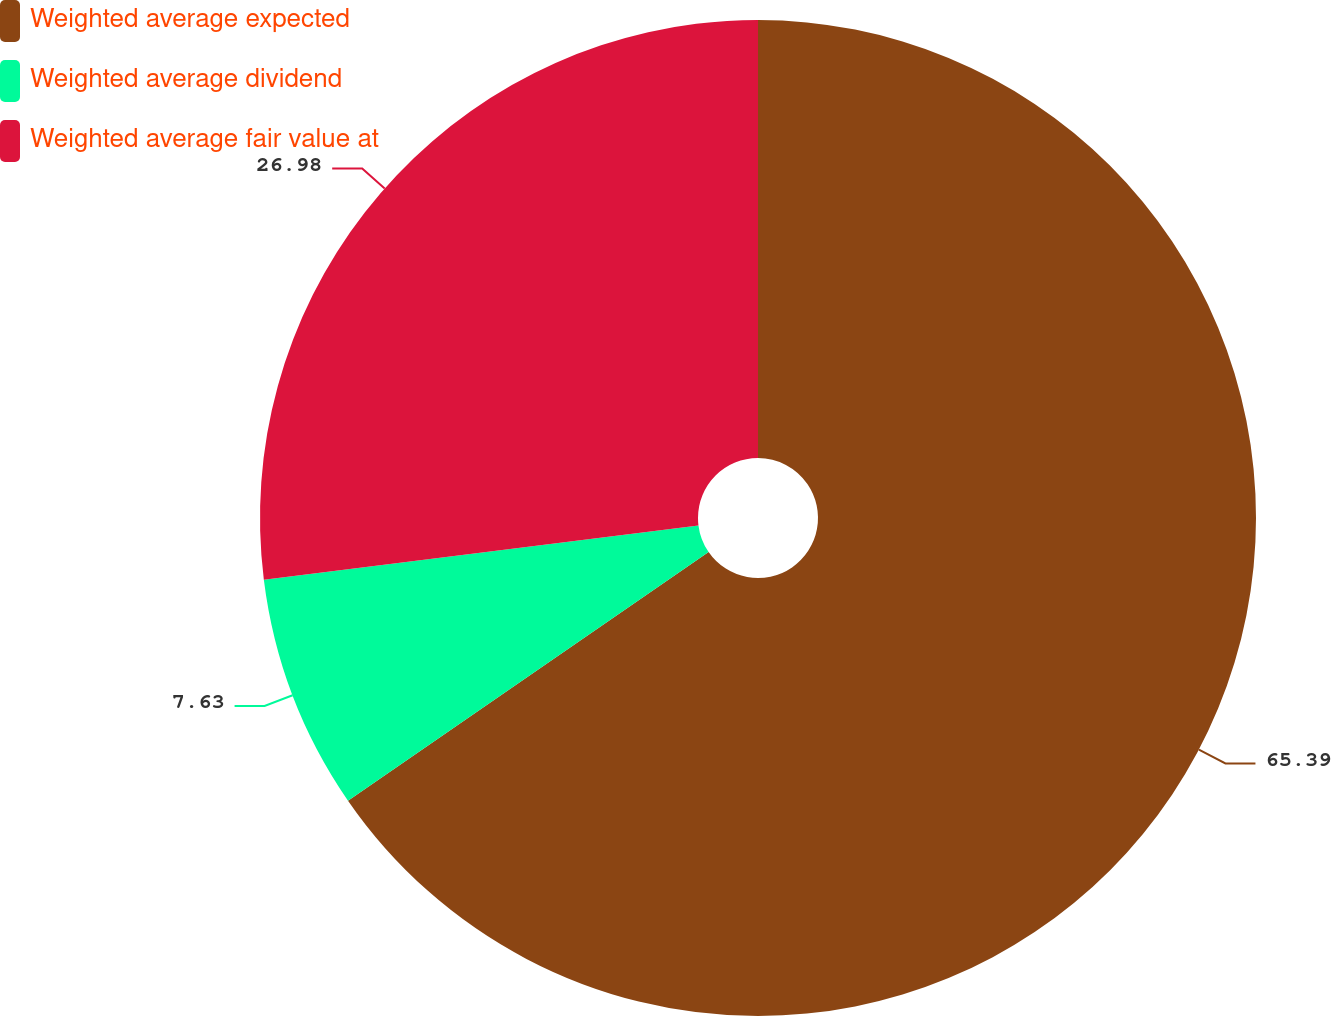Convert chart. <chart><loc_0><loc_0><loc_500><loc_500><pie_chart><fcel>Weighted average expected<fcel>Weighted average dividend<fcel>Weighted average fair value at<nl><fcel>65.4%<fcel>7.63%<fcel>26.98%<nl></chart> 